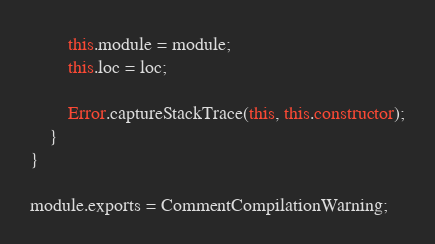<code> <loc_0><loc_0><loc_500><loc_500><_JavaScript_>		this.module = module;
		this.loc = loc;

		Error.captureStackTrace(this, this.constructor);
	}
}

module.exports = CommentCompilationWarning;
</code> 